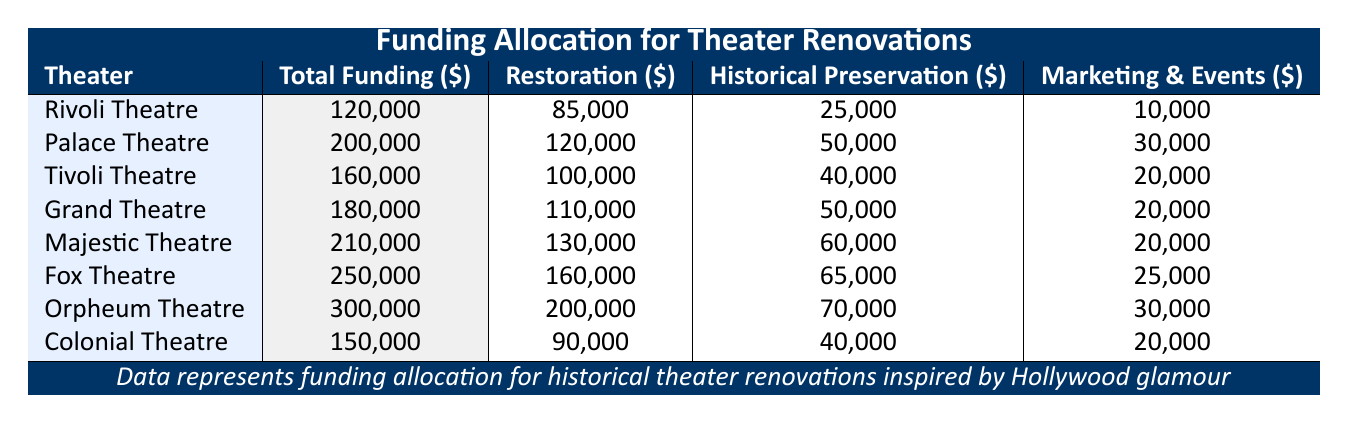What is the total funding for the Fox Theatre? The total funding for the Fox Theatre is explicitly listed in the table, under the "Total Funding" column. The value is 250,000.
Answer: 250,000 How much is allocated for restoration costs at the Orpheum Theatre? The restoration costs for the Orpheum Theatre are stated in the table under the "Restoration" column. The value is 200,000.
Answer: 200,000 Which theater has the highest marketing and events costs? Comparing the values in the "Marketing & Events" column, the Orpheum Theatre and the Palace Theatre both have costs of 30,000 and 30,000 respectively, which are the highest values in that column. Therefore, it is tied between the two.
Answer: Orpheum Theatre and Palace Theatre What is the total amount allocated for historical preservation across all theaters? To find the total amount allocated for historical preservation, sum up the values in the "Historical Preservation" column: 25,000 + 50,000 + 40,000 + 50,000 + 60,000 + 65,000 + 70,000 + 40,000 = 400,000.
Answer: 400,000 Is the total funding for the Rivoli Theatre greater than the average total funding for all theaters? First, compute the total funding for all theaters: 120,000 + 200,000 + 160,000 + 180,000 + 210,000 + 250,000 + 300,000 + 150,000 = 1,570,000. There are 8 theaters, so the average is 1,570,000 / 8 = 196,250. The Rivoli Theatre has total funding of 120,000, which is less than the average.
Answer: No What percentage of the total funding for the Majestic Theatre is assigned to historical preservation costs? The historical preservation costs for the Majestic Theatre are 60,000. The total funding for this theater is 210,000. To find the percentage, calculate (60,000 / 210,000) * 100 = 28.57%.
Answer: Approximately 28.57% Which theater underwent the least restoration costs, and what is that amount? By examining the "Restoration" column, the Colonial Theatre has the lowest restoration costs of 90,000.
Answer: Colonial Theatre, 90,000 How much more funding is allocated to the Orpheum Theatre than to the Colonial Theatre? Subtract the total funding of the Colonial Theatre (150,000) from the total funding of the Orpheum Theatre (300,000). The difference is 300,000 - 150,000 = 150,000.
Answer: 150,000 Does the Grand Theatre receive more total funding than the Tivoli Theatre? Comparing the values in the "Total Funding" column, the Grand Theatre has 180,000 while the Tivoli Theatre has 160,000. Since 180,000 is greater than 160,000, the statement is true.
Answer: Yes 